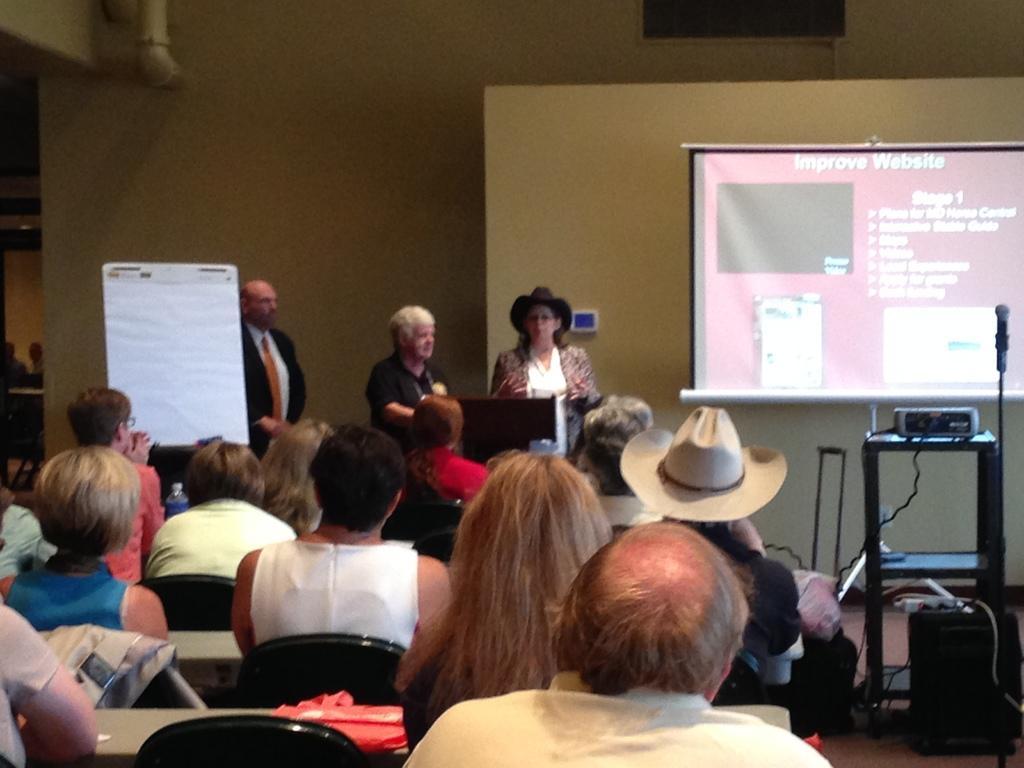Please provide a concise description of this image. In this image, we can see a few people. Among them, some people are sitting on chairs and some people are standing. We can also see a projector screen and a table with a device on it. There is a microphone. We can see a board and the ground with some objects. We can see the wall. 